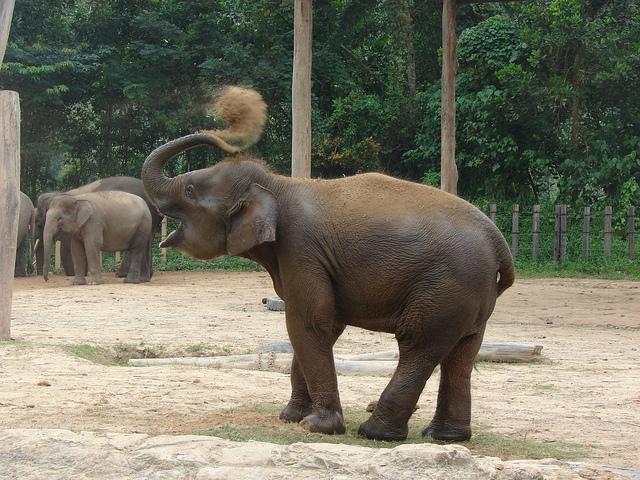How many elephant legs are in this picture?
Quick response, please. 9. Where is the log?
Give a very brief answer. Behind elephant. Does the elephant look like he is sneezing?
Concise answer only. Yes. What is the animal touching?
Keep it brief. Ground. What is on the elephant?
Write a very short answer. Dirt. Is the elephant's trunk in a natural position?
Answer briefly. Yes. Which direction is this elephant pointing his trunk?
Short answer required. Up. 